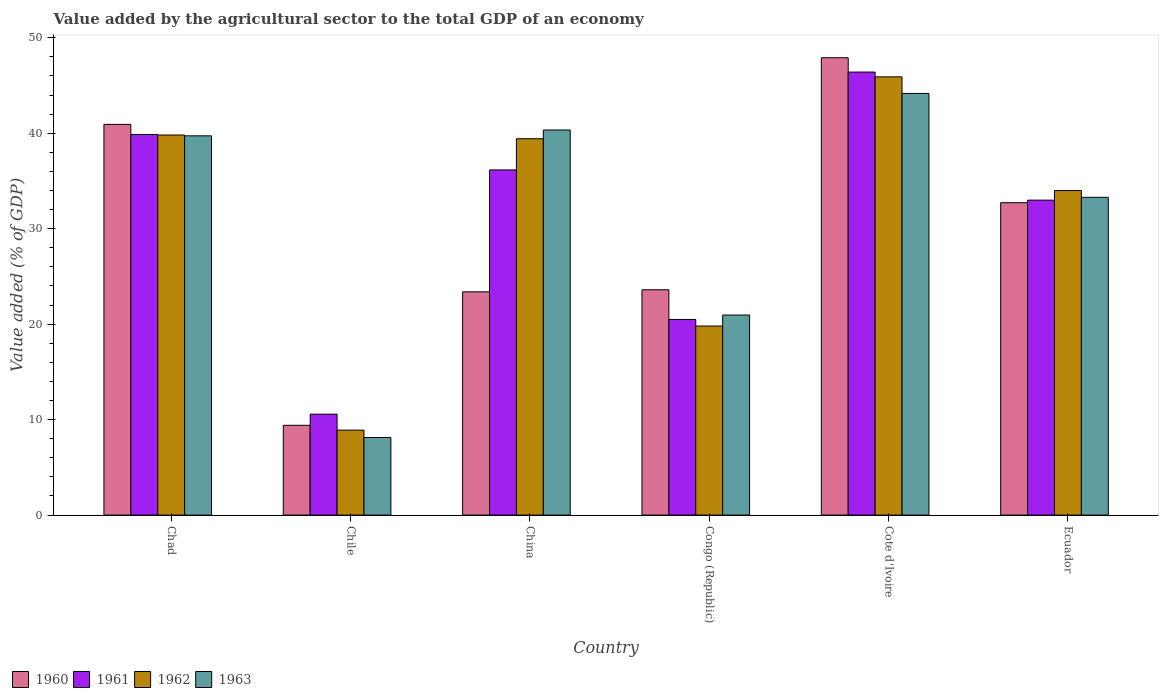How many different coloured bars are there?
Your answer should be very brief. 4. How many groups of bars are there?
Offer a terse response. 6. Are the number of bars per tick equal to the number of legend labels?
Provide a short and direct response. Yes. What is the label of the 3rd group of bars from the left?
Ensure brevity in your answer.  China. What is the value added by the agricultural sector to the total GDP in 1961 in Ecuador?
Give a very brief answer. 32.99. Across all countries, what is the maximum value added by the agricultural sector to the total GDP in 1963?
Offer a terse response. 44.17. Across all countries, what is the minimum value added by the agricultural sector to the total GDP in 1963?
Your response must be concise. 8.13. In which country was the value added by the agricultural sector to the total GDP in 1960 maximum?
Give a very brief answer. Cote d'Ivoire. In which country was the value added by the agricultural sector to the total GDP in 1963 minimum?
Provide a succinct answer. Chile. What is the total value added by the agricultural sector to the total GDP in 1960 in the graph?
Offer a very short reply. 177.94. What is the difference between the value added by the agricultural sector to the total GDP in 1961 in Cote d'Ivoire and that in Ecuador?
Make the answer very short. 13.42. What is the difference between the value added by the agricultural sector to the total GDP in 1961 in Ecuador and the value added by the agricultural sector to the total GDP in 1960 in Chile?
Your answer should be very brief. 23.59. What is the average value added by the agricultural sector to the total GDP in 1962 per country?
Your answer should be very brief. 31.31. What is the difference between the value added by the agricultural sector to the total GDP of/in 1962 and value added by the agricultural sector to the total GDP of/in 1963 in Cote d'Ivoire?
Offer a very short reply. 1.74. In how many countries, is the value added by the agricultural sector to the total GDP in 1962 greater than 12 %?
Keep it short and to the point. 5. What is the ratio of the value added by the agricultural sector to the total GDP in 1962 in Congo (Republic) to that in Cote d'Ivoire?
Provide a short and direct response. 0.43. Is the difference between the value added by the agricultural sector to the total GDP in 1962 in Congo (Republic) and Ecuador greater than the difference between the value added by the agricultural sector to the total GDP in 1963 in Congo (Republic) and Ecuador?
Offer a terse response. No. What is the difference between the highest and the second highest value added by the agricultural sector to the total GDP in 1961?
Give a very brief answer. -10.25. What is the difference between the highest and the lowest value added by the agricultural sector to the total GDP in 1963?
Keep it short and to the point. 36.04. In how many countries, is the value added by the agricultural sector to the total GDP in 1962 greater than the average value added by the agricultural sector to the total GDP in 1962 taken over all countries?
Ensure brevity in your answer.  4. Is the sum of the value added by the agricultural sector to the total GDP in 1963 in Chad and China greater than the maximum value added by the agricultural sector to the total GDP in 1961 across all countries?
Your answer should be very brief. Yes. What does the 4th bar from the left in Chad represents?
Offer a terse response. 1963. What does the 1st bar from the right in Chad represents?
Offer a very short reply. 1963. How many bars are there?
Make the answer very short. 24. Are all the bars in the graph horizontal?
Offer a terse response. No. What is the difference between two consecutive major ticks on the Y-axis?
Your response must be concise. 10. Where does the legend appear in the graph?
Give a very brief answer. Bottom left. How many legend labels are there?
Provide a succinct answer. 4. How are the legend labels stacked?
Provide a short and direct response. Horizontal. What is the title of the graph?
Keep it short and to the point. Value added by the agricultural sector to the total GDP of an economy. Does "1978" appear as one of the legend labels in the graph?
Your answer should be compact. No. What is the label or title of the X-axis?
Offer a terse response. Country. What is the label or title of the Y-axis?
Provide a succinct answer. Value added (% of GDP). What is the Value added (% of GDP) in 1960 in Chad?
Ensure brevity in your answer.  40.93. What is the Value added (% of GDP) of 1961 in Chad?
Your response must be concise. 39.87. What is the Value added (% of GDP) in 1962 in Chad?
Keep it short and to the point. 39.81. What is the Value added (% of GDP) of 1963 in Chad?
Your answer should be very brief. 39.73. What is the Value added (% of GDP) of 1960 in Chile?
Make the answer very short. 9.4. What is the Value added (% of GDP) of 1961 in Chile?
Ensure brevity in your answer.  10.57. What is the Value added (% of GDP) of 1962 in Chile?
Give a very brief answer. 8.9. What is the Value added (% of GDP) in 1963 in Chile?
Make the answer very short. 8.13. What is the Value added (% of GDP) in 1960 in China?
Provide a succinct answer. 23.38. What is the Value added (% of GDP) of 1961 in China?
Offer a very short reply. 36.16. What is the Value added (% of GDP) in 1962 in China?
Offer a terse response. 39.42. What is the Value added (% of GDP) of 1963 in China?
Your answer should be compact. 40.34. What is the Value added (% of GDP) in 1960 in Congo (Republic)?
Provide a short and direct response. 23.6. What is the Value added (% of GDP) in 1961 in Congo (Republic)?
Your answer should be compact. 20.49. What is the Value added (% of GDP) in 1962 in Congo (Republic)?
Your answer should be compact. 19.8. What is the Value added (% of GDP) in 1963 in Congo (Republic)?
Ensure brevity in your answer.  20.95. What is the Value added (% of GDP) in 1960 in Cote d'Ivoire?
Your response must be concise. 47.91. What is the Value added (% of GDP) of 1961 in Cote d'Ivoire?
Give a very brief answer. 46.41. What is the Value added (% of GDP) in 1962 in Cote d'Ivoire?
Make the answer very short. 45.9. What is the Value added (% of GDP) of 1963 in Cote d'Ivoire?
Give a very brief answer. 44.17. What is the Value added (% of GDP) in 1960 in Ecuador?
Make the answer very short. 32.72. What is the Value added (% of GDP) of 1961 in Ecuador?
Your answer should be compact. 32.99. What is the Value added (% of GDP) in 1962 in Ecuador?
Ensure brevity in your answer.  33.99. What is the Value added (% of GDP) in 1963 in Ecuador?
Your answer should be very brief. 33.29. Across all countries, what is the maximum Value added (% of GDP) in 1960?
Provide a short and direct response. 47.91. Across all countries, what is the maximum Value added (% of GDP) in 1961?
Provide a short and direct response. 46.41. Across all countries, what is the maximum Value added (% of GDP) in 1962?
Provide a short and direct response. 45.9. Across all countries, what is the maximum Value added (% of GDP) of 1963?
Give a very brief answer. 44.17. Across all countries, what is the minimum Value added (% of GDP) in 1960?
Ensure brevity in your answer.  9.4. Across all countries, what is the minimum Value added (% of GDP) of 1961?
Make the answer very short. 10.57. Across all countries, what is the minimum Value added (% of GDP) of 1962?
Your answer should be very brief. 8.9. Across all countries, what is the minimum Value added (% of GDP) in 1963?
Your answer should be compact. 8.13. What is the total Value added (% of GDP) in 1960 in the graph?
Your answer should be very brief. 177.94. What is the total Value added (% of GDP) in 1961 in the graph?
Provide a short and direct response. 186.48. What is the total Value added (% of GDP) in 1962 in the graph?
Your answer should be compact. 187.84. What is the total Value added (% of GDP) of 1963 in the graph?
Ensure brevity in your answer.  186.6. What is the difference between the Value added (% of GDP) in 1960 in Chad and that in Chile?
Make the answer very short. 31.52. What is the difference between the Value added (% of GDP) in 1961 in Chad and that in Chile?
Your answer should be compact. 29.3. What is the difference between the Value added (% of GDP) in 1962 in Chad and that in Chile?
Your answer should be compact. 30.91. What is the difference between the Value added (% of GDP) of 1963 in Chad and that in Chile?
Your response must be concise. 31.6. What is the difference between the Value added (% of GDP) of 1960 in Chad and that in China?
Your answer should be compact. 17.54. What is the difference between the Value added (% of GDP) of 1961 in Chad and that in China?
Offer a very short reply. 3.71. What is the difference between the Value added (% of GDP) in 1962 in Chad and that in China?
Offer a terse response. 0.39. What is the difference between the Value added (% of GDP) in 1963 in Chad and that in China?
Ensure brevity in your answer.  -0.61. What is the difference between the Value added (% of GDP) of 1960 in Chad and that in Congo (Republic)?
Provide a succinct answer. 17.33. What is the difference between the Value added (% of GDP) in 1961 in Chad and that in Congo (Republic)?
Provide a short and direct response. 19.38. What is the difference between the Value added (% of GDP) in 1962 in Chad and that in Congo (Republic)?
Give a very brief answer. 20.01. What is the difference between the Value added (% of GDP) in 1963 in Chad and that in Congo (Republic)?
Keep it short and to the point. 18.77. What is the difference between the Value added (% of GDP) of 1960 in Chad and that in Cote d'Ivoire?
Provide a succinct answer. -6.98. What is the difference between the Value added (% of GDP) of 1961 in Chad and that in Cote d'Ivoire?
Make the answer very short. -6.54. What is the difference between the Value added (% of GDP) of 1962 in Chad and that in Cote d'Ivoire?
Give a very brief answer. -6.09. What is the difference between the Value added (% of GDP) of 1963 in Chad and that in Cote d'Ivoire?
Give a very brief answer. -4.44. What is the difference between the Value added (% of GDP) in 1960 in Chad and that in Ecuador?
Keep it short and to the point. 8.21. What is the difference between the Value added (% of GDP) of 1961 in Chad and that in Ecuador?
Keep it short and to the point. 6.88. What is the difference between the Value added (% of GDP) of 1962 in Chad and that in Ecuador?
Your answer should be compact. 5.82. What is the difference between the Value added (% of GDP) of 1963 in Chad and that in Ecuador?
Offer a very short reply. 6.44. What is the difference between the Value added (% of GDP) of 1960 in Chile and that in China?
Provide a short and direct response. -13.98. What is the difference between the Value added (% of GDP) of 1961 in Chile and that in China?
Offer a very short reply. -25.58. What is the difference between the Value added (% of GDP) in 1962 in Chile and that in China?
Give a very brief answer. -30.52. What is the difference between the Value added (% of GDP) of 1963 in Chile and that in China?
Make the answer very short. -32.21. What is the difference between the Value added (% of GDP) of 1960 in Chile and that in Congo (Republic)?
Provide a short and direct response. -14.2. What is the difference between the Value added (% of GDP) of 1961 in Chile and that in Congo (Republic)?
Your answer should be compact. -9.92. What is the difference between the Value added (% of GDP) of 1962 in Chile and that in Congo (Republic)?
Make the answer very short. -10.91. What is the difference between the Value added (% of GDP) in 1963 in Chile and that in Congo (Republic)?
Offer a very short reply. -12.83. What is the difference between the Value added (% of GDP) in 1960 in Chile and that in Cote d'Ivoire?
Your answer should be very brief. -38.5. What is the difference between the Value added (% of GDP) in 1961 in Chile and that in Cote d'Ivoire?
Offer a very short reply. -35.84. What is the difference between the Value added (% of GDP) in 1962 in Chile and that in Cote d'Ivoire?
Ensure brevity in your answer.  -37. What is the difference between the Value added (% of GDP) of 1963 in Chile and that in Cote d'Ivoire?
Your answer should be very brief. -36.04. What is the difference between the Value added (% of GDP) in 1960 in Chile and that in Ecuador?
Provide a succinct answer. -23.32. What is the difference between the Value added (% of GDP) of 1961 in Chile and that in Ecuador?
Offer a very short reply. -22.42. What is the difference between the Value added (% of GDP) in 1962 in Chile and that in Ecuador?
Keep it short and to the point. -25.09. What is the difference between the Value added (% of GDP) of 1963 in Chile and that in Ecuador?
Keep it short and to the point. -25.16. What is the difference between the Value added (% of GDP) in 1960 in China and that in Congo (Republic)?
Your response must be concise. -0.22. What is the difference between the Value added (% of GDP) in 1961 in China and that in Congo (Republic)?
Your answer should be compact. 15.66. What is the difference between the Value added (% of GDP) in 1962 in China and that in Congo (Republic)?
Provide a short and direct response. 19.62. What is the difference between the Value added (% of GDP) in 1963 in China and that in Congo (Republic)?
Ensure brevity in your answer.  19.38. What is the difference between the Value added (% of GDP) in 1960 in China and that in Cote d'Ivoire?
Offer a very short reply. -24.52. What is the difference between the Value added (% of GDP) of 1961 in China and that in Cote d'Ivoire?
Your answer should be very brief. -10.25. What is the difference between the Value added (% of GDP) in 1962 in China and that in Cote d'Ivoire?
Offer a terse response. -6.48. What is the difference between the Value added (% of GDP) of 1963 in China and that in Cote d'Ivoire?
Your answer should be very brief. -3.83. What is the difference between the Value added (% of GDP) in 1960 in China and that in Ecuador?
Keep it short and to the point. -9.34. What is the difference between the Value added (% of GDP) in 1961 in China and that in Ecuador?
Provide a short and direct response. 3.17. What is the difference between the Value added (% of GDP) in 1962 in China and that in Ecuador?
Your answer should be compact. 5.43. What is the difference between the Value added (% of GDP) in 1963 in China and that in Ecuador?
Your answer should be compact. 7.05. What is the difference between the Value added (% of GDP) of 1960 in Congo (Republic) and that in Cote d'Ivoire?
Give a very brief answer. -24.31. What is the difference between the Value added (% of GDP) in 1961 in Congo (Republic) and that in Cote d'Ivoire?
Offer a very short reply. -25.91. What is the difference between the Value added (% of GDP) of 1962 in Congo (Republic) and that in Cote d'Ivoire?
Your answer should be compact. -26.1. What is the difference between the Value added (% of GDP) of 1963 in Congo (Republic) and that in Cote d'Ivoire?
Offer a terse response. -23.21. What is the difference between the Value added (% of GDP) in 1960 in Congo (Republic) and that in Ecuador?
Offer a terse response. -9.12. What is the difference between the Value added (% of GDP) in 1961 in Congo (Republic) and that in Ecuador?
Your response must be concise. -12.5. What is the difference between the Value added (% of GDP) of 1962 in Congo (Republic) and that in Ecuador?
Keep it short and to the point. -14.19. What is the difference between the Value added (% of GDP) in 1963 in Congo (Republic) and that in Ecuador?
Offer a terse response. -12.33. What is the difference between the Value added (% of GDP) of 1960 in Cote d'Ivoire and that in Ecuador?
Make the answer very short. 15.19. What is the difference between the Value added (% of GDP) of 1961 in Cote d'Ivoire and that in Ecuador?
Make the answer very short. 13.42. What is the difference between the Value added (% of GDP) in 1962 in Cote d'Ivoire and that in Ecuador?
Keep it short and to the point. 11.91. What is the difference between the Value added (% of GDP) in 1963 in Cote d'Ivoire and that in Ecuador?
Provide a succinct answer. 10.88. What is the difference between the Value added (% of GDP) in 1960 in Chad and the Value added (% of GDP) in 1961 in Chile?
Your response must be concise. 30.36. What is the difference between the Value added (% of GDP) in 1960 in Chad and the Value added (% of GDP) in 1962 in Chile?
Your answer should be compact. 32.03. What is the difference between the Value added (% of GDP) of 1960 in Chad and the Value added (% of GDP) of 1963 in Chile?
Offer a terse response. 32.8. What is the difference between the Value added (% of GDP) of 1961 in Chad and the Value added (% of GDP) of 1962 in Chile?
Offer a terse response. 30.97. What is the difference between the Value added (% of GDP) in 1961 in Chad and the Value added (% of GDP) in 1963 in Chile?
Offer a very short reply. 31.74. What is the difference between the Value added (% of GDP) in 1962 in Chad and the Value added (% of GDP) in 1963 in Chile?
Provide a short and direct response. 31.69. What is the difference between the Value added (% of GDP) in 1960 in Chad and the Value added (% of GDP) in 1961 in China?
Make the answer very short. 4.77. What is the difference between the Value added (% of GDP) of 1960 in Chad and the Value added (% of GDP) of 1962 in China?
Make the answer very short. 1.5. What is the difference between the Value added (% of GDP) in 1960 in Chad and the Value added (% of GDP) in 1963 in China?
Provide a succinct answer. 0.59. What is the difference between the Value added (% of GDP) in 1961 in Chad and the Value added (% of GDP) in 1962 in China?
Your answer should be compact. 0.44. What is the difference between the Value added (% of GDP) in 1961 in Chad and the Value added (% of GDP) in 1963 in China?
Provide a succinct answer. -0.47. What is the difference between the Value added (% of GDP) of 1962 in Chad and the Value added (% of GDP) of 1963 in China?
Provide a succinct answer. -0.53. What is the difference between the Value added (% of GDP) of 1960 in Chad and the Value added (% of GDP) of 1961 in Congo (Republic)?
Your answer should be compact. 20.44. What is the difference between the Value added (% of GDP) of 1960 in Chad and the Value added (% of GDP) of 1962 in Congo (Republic)?
Ensure brevity in your answer.  21.12. What is the difference between the Value added (% of GDP) of 1960 in Chad and the Value added (% of GDP) of 1963 in Congo (Republic)?
Keep it short and to the point. 19.97. What is the difference between the Value added (% of GDP) of 1961 in Chad and the Value added (% of GDP) of 1962 in Congo (Republic)?
Provide a short and direct response. 20.06. What is the difference between the Value added (% of GDP) in 1961 in Chad and the Value added (% of GDP) in 1963 in Congo (Republic)?
Make the answer very short. 18.91. What is the difference between the Value added (% of GDP) in 1962 in Chad and the Value added (% of GDP) in 1963 in Congo (Republic)?
Provide a succinct answer. 18.86. What is the difference between the Value added (% of GDP) in 1960 in Chad and the Value added (% of GDP) in 1961 in Cote d'Ivoire?
Give a very brief answer. -5.48. What is the difference between the Value added (% of GDP) of 1960 in Chad and the Value added (% of GDP) of 1962 in Cote d'Ivoire?
Offer a terse response. -4.98. What is the difference between the Value added (% of GDP) in 1960 in Chad and the Value added (% of GDP) in 1963 in Cote d'Ivoire?
Offer a very short reply. -3.24. What is the difference between the Value added (% of GDP) in 1961 in Chad and the Value added (% of GDP) in 1962 in Cote d'Ivoire?
Keep it short and to the point. -6.04. What is the difference between the Value added (% of GDP) in 1961 in Chad and the Value added (% of GDP) in 1963 in Cote d'Ivoire?
Offer a very short reply. -4.3. What is the difference between the Value added (% of GDP) in 1962 in Chad and the Value added (% of GDP) in 1963 in Cote d'Ivoire?
Ensure brevity in your answer.  -4.36. What is the difference between the Value added (% of GDP) in 1960 in Chad and the Value added (% of GDP) in 1961 in Ecuador?
Provide a succinct answer. 7.94. What is the difference between the Value added (% of GDP) of 1960 in Chad and the Value added (% of GDP) of 1962 in Ecuador?
Make the answer very short. 6.93. What is the difference between the Value added (% of GDP) of 1960 in Chad and the Value added (% of GDP) of 1963 in Ecuador?
Your response must be concise. 7.64. What is the difference between the Value added (% of GDP) of 1961 in Chad and the Value added (% of GDP) of 1962 in Ecuador?
Provide a short and direct response. 5.87. What is the difference between the Value added (% of GDP) of 1961 in Chad and the Value added (% of GDP) of 1963 in Ecuador?
Keep it short and to the point. 6.58. What is the difference between the Value added (% of GDP) in 1962 in Chad and the Value added (% of GDP) in 1963 in Ecuador?
Give a very brief answer. 6.52. What is the difference between the Value added (% of GDP) in 1960 in Chile and the Value added (% of GDP) in 1961 in China?
Provide a short and direct response. -26.75. What is the difference between the Value added (% of GDP) in 1960 in Chile and the Value added (% of GDP) in 1962 in China?
Give a very brief answer. -30.02. What is the difference between the Value added (% of GDP) in 1960 in Chile and the Value added (% of GDP) in 1963 in China?
Offer a terse response. -30.93. What is the difference between the Value added (% of GDP) of 1961 in Chile and the Value added (% of GDP) of 1962 in China?
Give a very brief answer. -28.85. What is the difference between the Value added (% of GDP) of 1961 in Chile and the Value added (% of GDP) of 1963 in China?
Provide a short and direct response. -29.77. What is the difference between the Value added (% of GDP) of 1962 in Chile and the Value added (% of GDP) of 1963 in China?
Your response must be concise. -31.44. What is the difference between the Value added (% of GDP) of 1960 in Chile and the Value added (% of GDP) of 1961 in Congo (Republic)?
Your response must be concise. -11.09. What is the difference between the Value added (% of GDP) in 1960 in Chile and the Value added (% of GDP) in 1962 in Congo (Republic)?
Your answer should be compact. -10.4. What is the difference between the Value added (% of GDP) in 1960 in Chile and the Value added (% of GDP) in 1963 in Congo (Republic)?
Ensure brevity in your answer.  -11.55. What is the difference between the Value added (% of GDP) of 1961 in Chile and the Value added (% of GDP) of 1962 in Congo (Republic)?
Your answer should be compact. -9.23. What is the difference between the Value added (% of GDP) of 1961 in Chile and the Value added (% of GDP) of 1963 in Congo (Republic)?
Make the answer very short. -10.38. What is the difference between the Value added (% of GDP) of 1962 in Chile and the Value added (% of GDP) of 1963 in Congo (Republic)?
Provide a succinct answer. -12.05. What is the difference between the Value added (% of GDP) in 1960 in Chile and the Value added (% of GDP) in 1961 in Cote d'Ivoire?
Keep it short and to the point. -37. What is the difference between the Value added (% of GDP) in 1960 in Chile and the Value added (% of GDP) in 1962 in Cote d'Ivoire?
Provide a short and direct response. -36.5. What is the difference between the Value added (% of GDP) of 1960 in Chile and the Value added (% of GDP) of 1963 in Cote d'Ivoire?
Offer a very short reply. -34.76. What is the difference between the Value added (% of GDP) in 1961 in Chile and the Value added (% of GDP) in 1962 in Cote d'Ivoire?
Make the answer very short. -35.33. What is the difference between the Value added (% of GDP) in 1961 in Chile and the Value added (% of GDP) in 1963 in Cote d'Ivoire?
Your response must be concise. -33.6. What is the difference between the Value added (% of GDP) of 1962 in Chile and the Value added (% of GDP) of 1963 in Cote d'Ivoire?
Give a very brief answer. -35.27. What is the difference between the Value added (% of GDP) in 1960 in Chile and the Value added (% of GDP) in 1961 in Ecuador?
Make the answer very short. -23.59. What is the difference between the Value added (% of GDP) in 1960 in Chile and the Value added (% of GDP) in 1962 in Ecuador?
Keep it short and to the point. -24.59. What is the difference between the Value added (% of GDP) of 1960 in Chile and the Value added (% of GDP) of 1963 in Ecuador?
Give a very brief answer. -23.88. What is the difference between the Value added (% of GDP) in 1961 in Chile and the Value added (% of GDP) in 1962 in Ecuador?
Your answer should be compact. -23.42. What is the difference between the Value added (% of GDP) in 1961 in Chile and the Value added (% of GDP) in 1963 in Ecuador?
Ensure brevity in your answer.  -22.72. What is the difference between the Value added (% of GDP) of 1962 in Chile and the Value added (% of GDP) of 1963 in Ecuador?
Keep it short and to the point. -24.39. What is the difference between the Value added (% of GDP) of 1960 in China and the Value added (% of GDP) of 1961 in Congo (Republic)?
Offer a very short reply. 2.89. What is the difference between the Value added (% of GDP) of 1960 in China and the Value added (% of GDP) of 1962 in Congo (Republic)?
Your answer should be compact. 3.58. What is the difference between the Value added (% of GDP) of 1960 in China and the Value added (% of GDP) of 1963 in Congo (Republic)?
Offer a terse response. 2.43. What is the difference between the Value added (% of GDP) of 1961 in China and the Value added (% of GDP) of 1962 in Congo (Republic)?
Make the answer very short. 16.35. What is the difference between the Value added (% of GDP) in 1961 in China and the Value added (% of GDP) in 1963 in Congo (Republic)?
Make the answer very short. 15.2. What is the difference between the Value added (% of GDP) in 1962 in China and the Value added (% of GDP) in 1963 in Congo (Republic)?
Give a very brief answer. 18.47. What is the difference between the Value added (% of GDP) in 1960 in China and the Value added (% of GDP) in 1961 in Cote d'Ivoire?
Offer a very short reply. -23.02. What is the difference between the Value added (% of GDP) of 1960 in China and the Value added (% of GDP) of 1962 in Cote d'Ivoire?
Ensure brevity in your answer.  -22.52. What is the difference between the Value added (% of GDP) of 1960 in China and the Value added (% of GDP) of 1963 in Cote d'Ivoire?
Keep it short and to the point. -20.78. What is the difference between the Value added (% of GDP) of 1961 in China and the Value added (% of GDP) of 1962 in Cote d'Ivoire?
Offer a terse response. -9.75. What is the difference between the Value added (% of GDP) of 1961 in China and the Value added (% of GDP) of 1963 in Cote d'Ivoire?
Offer a terse response. -8.01. What is the difference between the Value added (% of GDP) in 1962 in China and the Value added (% of GDP) in 1963 in Cote d'Ivoire?
Make the answer very short. -4.74. What is the difference between the Value added (% of GDP) in 1960 in China and the Value added (% of GDP) in 1961 in Ecuador?
Make the answer very short. -9.61. What is the difference between the Value added (% of GDP) in 1960 in China and the Value added (% of GDP) in 1962 in Ecuador?
Your response must be concise. -10.61. What is the difference between the Value added (% of GDP) of 1960 in China and the Value added (% of GDP) of 1963 in Ecuador?
Offer a terse response. -9.9. What is the difference between the Value added (% of GDP) of 1961 in China and the Value added (% of GDP) of 1962 in Ecuador?
Your answer should be very brief. 2.16. What is the difference between the Value added (% of GDP) in 1961 in China and the Value added (% of GDP) in 1963 in Ecuador?
Make the answer very short. 2.87. What is the difference between the Value added (% of GDP) of 1962 in China and the Value added (% of GDP) of 1963 in Ecuador?
Make the answer very short. 6.14. What is the difference between the Value added (% of GDP) of 1960 in Congo (Republic) and the Value added (% of GDP) of 1961 in Cote d'Ivoire?
Provide a short and direct response. -22.81. What is the difference between the Value added (% of GDP) of 1960 in Congo (Republic) and the Value added (% of GDP) of 1962 in Cote d'Ivoire?
Your response must be concise. -22.3. What is the difference between the Value added (% of GDP) in 1960 in Congo (Republic) and the Value added (% of GDP) in 1963 in Cote d'Ivoire?
Offer a very short reply. -20.57. What is the difference between the Value added (% of GDP) of 1961 in Congo (Republic) and the Value added (% of GDP) of 1962 in Cote d'Ivoire?
Make the answer very short. -25.41. What is the difference between the Value added (% of GDP) of 1961 in Congo (Republic) and the Value added (% of GDP) of 1963 in Cote d'Ivoire?
Your answer should be compact. -23.68. What is the difference between the Value added (% of GDP) in 1962 in Congo (Republic) and the Value added (% of GDP) in 1963 in Cote d'Ivoire?
Offer a very short reply. -24.36. What is the difference between the Value added (% of GDP) in 1960 in Congo (Republic) and the Value added (% of GDP) in 1961 in Ecuador?
Offer a very short reply. -9.39. What is the difference between the Value added (% of GDP) in 1960 in Congo (Republic) and the Value added (% of GDP) in 1962 in Ecuador?
Your answer should be very brief. -10.39. What is the difference between the Value added (% of GDP) of 1960 in Congo (Republic) and the Value added (% of GDP) of 1963 in Ecuador?
Keep it short and to the point. -9.69. What is the difference between the Value added (% of GDP) in 1961 in Congo (Republic) and the Value added (% of GDP) in 1962 in Ecuador?
Your answer should be compact. -13.5. What is the difference between the Value added (% of GDP) of 1961 in Congo (Republic) and the Value added (% of GDP) of 1963 in Ecuador?
Provide a short and direct response. -12.8. What is the difference between the Value added (% of GDP) of 1962 in Congo (Republic) and the Value added (% of GDP) of 1963 in Ecuador?
Offer a very short reply. -13.48. What is the difference between the Value added (% of GDP) of 1960 in Cote d'Ivoire and the Value added (% of GDP) of 1961 in Ecuador?
Give a very brief answer. 14.92. What is the difference between the Value added (% of GDP) in 1960 in Cote d'Ivoire and the Value added (% of GDP) in 1962 in Ecuador?
Make the answer very short. 13.91. What is the difference between the Value added (% of GDP) of 1960 in Cote d'Ivoire and the Value added (% of GDP) of 1963 in Ecuador?
Give a very brief answer. 14.62. What is the difference between the Value added (% of GDP) in 1961 in Cote d'Ivoire and the Value added (% of GDP) in 1962 in Ecuador?
Offer a very short reply. 12.41. What is the difference between the Value added (% of GDP) in 1961 in Cote d'Ivoire and the Value added (% of GDP) in 1963 in Ecuador?
Provide a short and direct response. 13.12. What is the difference between the Value added (% of GDP) of 1962 in Cote d'Ivoire and the Value added (% of GDP) of 1963 in Ecuador?
Ensure brevity in your answer.  12.62. What is the average Value added (% of GDP) of 1960 per country?
Provide a succinct answer. 29.66. What is the average Value added (% of GDP) in 1961 per country?
Offer a terse response. 31.08. What is the average Value added (% of GDP) in 1962 per country?
Ensure brevity in your answer.  31.31. What is the average Value added (% of GDP) in 1963 per country?
Your answer should be very brief. 31.1. What is the difference between the Value added (% of GDP) of 1960 and Value added (% of GDP) of 1961 in Chad?
Provide a short and direct response. 1.06. What is the difference between the Value added (% of GDP) of 1960 and Value added (% of GDP) of 1962 in Chad?
Provide a succinct answer. 1.11. What is the difference between the Value added (% of GDP) in 1960 and Value added (% of GDP) in 1963 in Chad?
Provide a short and direct response. 1.2. What is the difference between the Value added (% of GDP) in 1961 and Value added (% of GDP) in 1962 in Chad?
Give a very brief answer. 0.06. What is the difference between the Value added (% of GDP) of 1961 and Value added (% of GDP) of 1963 in Chad?
Ensure brevity in your answer.  0.14. What is the difference between the Value added (% of GDP) in 1962 and Value added (% of GDP) in 1963 in Chad?
Your response must be concise. 0.09. What is the difference between the Value added (% of GDP) in 1960 and Value added (% of GDP) in 1961 in Chile?
Offer a very short reply. -1.17. What is the difference between the Value added (% of GDP) of 1960 and Value added (% of GDP) of 1962 in Chile?
Ensure brevity in your answer.  0.51. What is the difference between the Value added (% of GDP) of 1960 and Value added (% of GDP) of 1963 in Chile?
Offer a terse response. 1.28. What is the difference between the Value added (% of GDP) in 1961 and Value added (% of GDP) in 1962 in Chile?
Offer a very short reply. 1.67. What is the difference between the Value added (% of GDP) in 1961 and Value added (% of GDP) in 1963 in Chile?
Provide a succinct answer. 2.45. What is the difference between the Value added (% of GDP) of 1962 and Value added (% of GDP) of 1963 in Chile?
Your answer should be compact. 0.77. What is the difference between the Value added (% of GDP) of 1960 and Value added (% of GDP) of 1961 in China?
Offer a very short reply. -12.77. What is the difference between the Value added (% of GDP) of 1960 and Value added (% of GDP) of 1962 in China?
Your answer should be compact. -16.04. What is the difference between the Value added (% of GDP) in 1960 and Value added (% of GDP) in 1963 in China?
Provide a short and direct response. -16.96. What is the difference between the Value added (% of GDP) in 1961 and Value added (% of GDP) in 1962 in China?
Give a very brief answer. -3.27. What is the difference between the Value added (% of GDP) of 1961 and Value added (% of GDP) of 1963 in China?
Your answer should be very brief. -4.18. What is the difference between the Value added (% of GDP) of 1962 and Value added (% of GDP) of 1963 in China?
Your response must be concise. -0.91. What is the difference between the Value added (% of GDP) of 1960 and Value added (% of GDP) of 1961 in Congo (Republic)?
Make the answer very short. 3.11. What is the difference between the Value added (% of GDP) of 1960 and Value added (% of GDP) of 1962 in Congo (Republic)?
Make the answer very short. 3.8. What is the difference between the Value added (% of GDP) of 1960 and Value added (% of GDP) of 1963 in Congo (Republic)?
Offer a very short reply. 2.65. What is the difference between the Value added (% of GDP) in 1961 and Value added (% of GDP) in 1962 in Congo (Republic)?
Ensure brevity in your answer.  0.69. What is the difference between the Value added (% of GDP) in 1961 and Value added (% of GDP) in 1963 in Congo (Republic)?
Your answer should be compact. -0.46. What is the difference between the Value added (% of GDP) of 1962 and Value added (% of GDP) of 1963 in Congo (Republic)?
Provide a succinct answer. -1.15. What is the difference between the Value added (% of GDP) of 1960 and Value added (% of GDP) of 1961 in Cote d'Ivoire?
Give a very brief answer. 1.5. What is the difference between the Value added (% of GDP) of 1960 and Value added (% of GDP) of 1962 in Cote d'Ivoire?
Give a very brief answer. 2. What is the difference between the Value added (% of GDP) in 1960 and Value added (% of GDP) in 1963 in Cote d'Ivoire?
Ensure brevity in your answer.  3.74. What is the difference between the Value added (% of GDP) in 1961 and Value added (% of GDP) in 1962 in Cote d'Ivoire?
Give a very brief answer. 0.5. What is the difference between the Value added (% of GDP) in 1961 and Value added (% of GDP) in 1963 in Cote d'Ivoire?
Give a very brief answer. 2.24. What is the difference between the Value added (% of GDP) of 1962 and Value added (% of GDP) of 1963 in Cote d'Ivoire?
Make the answer very short. 1.74. What is the difference between the Value added (% of GDP) of 1960 and Value added (% of GDP) of 1961 in Ecuador?
Provide a succinct answer. -0.27. What is the difference between the Value added (% of GDP) of 1960 and Value added (% of GDP) of 1962 in Ecuador?
Keep it short and to the point. -1.27. What is the difference between the Value added (% of GDP) in 1960 and Value added (% of GDP) in 1963 in Ecuador?
Ensure brevity in your answer.  -0.57. What is the difference between the Value added (% of GDP) of 1961 and Value added (% of GDP) of 1962 in Ecuador?
Offer a very short reply. -1. What is the difference between the Value added (% of GDP) of 1961 and Value added (% of GDP) of 1963 in Ecuador?
Ensure brevity in your answer.  -0.3. What is the difference between the Value added (% of GDP) in 1962 and Value added (% of GDP) in 1963 in Ecuador?
Keep it short and to the point. 0.71. What is the ratio of the Value added (% of GDP) in 1960 in Chad to that in Chile?
Your response must be concise. 4.35. What is the ratio of the Value added (% of GDP) of 1961 in Chad to that in Chile?
Keep it short and to the point. 3.77. What is the ratio of the Value added (% of GDP) in 1962 in Chad to that in Chile?
Make the answer very short. 4.47. What is the ratio of the Value added (% of GDP) in 1963 in Chad to that in Chile?
Your response must be concise. 4.89. What is the ratio of the Value added (% of GDP) in 1960 in Chad to that in China?
Your response must be concise. 1.75. What is the ratio of the Value added (% of GDP) of 1961 in Chad to that in China?
Give a very brief answer. 1.1. What is the ratio of the Value added (% of GDP) of 1962 in Chad to that in China?
Keep it short and to the point. 1.01. What is the ratio of the Value added (% of GDP) of 1963 in Chad to that in China?
Offer a very short reply. 0.98. What is the ratio of the Value added (% of GDP) of 1960 in Chad to that in Congo (Republic)?
Your answer should be compact. 1.73. What is the ratio of the Value added (% of GDP) in 1961 in Chad to that in Congo (Republic)?
Make the answer very short. 1.95. What is the ratio of the Value added (% of GDP) of 1962 in Chad to that in Congo (Republic)?
Provide a short and direct response. 2.01. What is the ratio of the Value added (% of GDP) in 1963 in Chad to that in Congo (Republic)?
Ensure brevity in your answer.  1.9. What is the ratio of the Value added (% of GDP) of 1960 in Chad to that in Cote d'Ivoire?
Provide a succinct answer. 0.85. What is the ratio of the Value added (% of GDP) of 1961 in Chad to that in Cote d'Ivoire?
Ensure brevity in your answer.  0.86. What is the ratio of the Value added (% of GDP) in 1962 in Chad to that in Cote d'Ivoire?
Make the answer very short. 0.87. What is the ratio of the Value added (% of GDP) of 1963 in Chad to that in Cote d'Ivoire?
Your answer should be very brief. 0.9. What is the ratio of the Value added (% of GDP) of 1960 in Chad to that in Ecuador?
Offer a very short reply. 1.25. What is the ratio of the Value added (% of GDP) in 1961 in Chad to that in Ecuador?
Give a very brief answer. 1.21. What is the ratio of the Value added (% of GDP) of 1962 in Chad to that in Ecuador?
Provide a short and direct response. 1.17. What is the ratio of the Value added (% of GDP) in 1963 in Chad to that in Ecuador?
Your answer should be very brief. 1.19. What is the ratio of the Value added (% of GDP) in 1960 in Chile to that in China?
Your answer should be compact. 0.4. What is the ratio of the Value added (% of GDP) of 1961 in Chile to that in China?
Your answer should be very brief. 0.29. What is the ratio of the Value added (% of GDP) of 1962 in Chile to that in China?
Offer a terse response. 0.23. What is the ratio of the Value added (% of GDP) in 1963 in Chile to that in China?
Provide a succinct answer. 0.2. What is the ratio of the Value added (% of GDP) of 1960 in Chile to that in Congo (Republic)?
Keep it short and to the point. 0.4. What is the ratio of the Value added (% of GDP) in 1961 in Chile to that in Congo (Republic)?
Keep it short and to the point. 0.52. What is the ratio of the Value added (% of GDP) in 1962 in Chile to that in Congo (Republic)?
Provide a succinct answer. 0.45. What is the ratio of the Value added (% of GDP) of 1963 in Chile to that in Congo (Republic)?
Provide a succinct answer. 0.39. What is the ratio of the Value added (% of GDP) of 1960 in Chile to that in Cote d'Ivoire?
Ensure brevity in your answer.  0.2. What is the ratio of the Value added (% of GDP) of 1961 in Chile to that in Cote d'Ivoire?
Give a very brief answer. 0.23. What is the ratio of the Value added (% of GDP) of 1962 in Chile to that in Cote d'Ivoire?
Provide a succinct answer. 0.19. What is the ratio of the Value added (% of GDP) in 1963 in Chile to that in Cote d'Ivoire?
Your answer should be very brief. 0.18. What is the ratio of the Value added (% of GDP) of 1960 in Chile to that in Ecuador?
Your response must be concise. 0.29. What is the ratio of the Value added (% of GDP) in 1961 in Chile to that in Ecuador?
Make the answer very short. 0.32. What is the ratio of the Value added (% of GDP) in 1962 in Chile to that in Ecuador?
Offer a very short reply. 0.26. What is the ratio of the Value added (% of GDP) of 1963 in Chile to that in Ecuador?
Your answer should be very brief. 0.24. What is the ratio of the Value added (% of GDP) in 1960 in China to that in Congo (Republic)?
Your response must be concise. 0.99. What is the ratio of the Value added (% of GDP) in 1961 in China to that in Congo (Republic)?
Offer a terse response. 1.76. What is the ratio of the Value added (% of GDP) in 1962 in China to that in Congo (Republic)?
Your answer should be very brief. 1.99. What is the ratio of the Value added (% of GDP) of 1963 in China to that in Congo (Republic)?
Offer a terse response. 1.93. What is the ratio of the Value added (% of GDP) in 1960 in China to that in Cote d'Ivoire?
Your answer should be very brief. 0.49. What is the ratio of the Value added (% of GDP) in 1961 in China to that in Cote d'Ivoire?
Your response must be concise. 0.78. What is the ratio of the Value added (% of GDP) in 1962 in China to that in Cote d'Ivoire?
Your answer should be compact. 0.86. What is the ratio of the Value added (% of GDP) of 1963 in China to that in Cote d'Ivoire?
Ensure brevity in your answer.  0.91. What is the ratio of the Value added (% of GDP) of 1960 in China to that in Ecuador?
Provide a short and direct response. 0.71. What is the ratio of the Value added (% of GDP) in 1961 in China to that in Ecuador?
Your response must be concise. 1.1. What is the ratio of the Value added (% of GDP) in 1962 in China to that in Ecuador?
Your answer should be compact. 1.16. What is the ratio of the Value added (% of GDP) in 1963 in China to that in Ecuador?
Offer a very short reply. 1.21. What is the ratio of the Value added (% of GDP) in 1960 in Congo (Republic) to that in Cote d'Ivoire?
Ensure brevity in your answer.  0.49. What is the ratio of the Value added (% of GDP) in 1961 in Congo (Republic) to that in Cote d'Ivoire?
Your response must be concise. 0.44. What is the ratio of the Value added (% of GDP) of 1962 in Congo (Republic) to that in Cote d'Ivoire?
Your response must be concise. 0.43. What is the ratio of the Value added (% of GDP) in 1963 in Congo (Republic) to that in Cote d'Ivoire?
Your answer should be compact. 0.47. What is the ratio of the Value added (% of GDP) of 1960 in Congo (Republic) to that in Ecuador?
Keep it short and to the point. 0.72. What is the ratio of the Value added (% of GDP) of 1961 in Congo (Republic) to that in Ecuador?
Your answer should be very brief. 0.62. What is the ratio of the Value added (% of GDP) of 1962 in Congo (Republic) to that in Ecuador?
Provide a short and direct response. 0.58. What is the ratio of the Value added (% of GDP) in 1963 in Congo (Republic) to that in Ecuador?
Ensure brevity in your answer.  0.63. What is the ratio of the Value added (% of GDP) of 1960 in Cote d'Ivoire to that in Ecuador?
Provide a succinct answer. 1.46. What is the ratio of the Value added (% of GDP) in 1961 in Cote d'Ivoire to that in Ecuador?
Offer a terse response. 1.41. What is the ratio of the Value added (% of GDP) in 1962 in Cote d'Ivoire to that in Ecuador?
Ensure brevity in your answer.  1.35. What is the ratio of the Value added (% of GDP) in 1963 in Cote d'Ivoire to that in Ecuador?
Your answer should be compact. 1.33. What is the difference between the highest and the second highest Value added (% of GDP) of 1960?
Keep it short and to the point. 6.98. What is the difference between the highest and the second highest Value added (% of GDP) of 1961?
Keep it short and to the point. 6.54. What is the difference between the highest and the second highest Value added (% of GDP) in 1962?
Offer a very short reply. 6.09. What is the difference between the highest and the second highest Value added (% of GDP) in 1963?
Your response must be concise. 3.83. What is the difference between the highest and the lowest Value added (% of GDP) of 1960?
Your answer should be compact. 38.5. What is the difference between the highest and the lowest Value added (% of GDP) in 1961?
Your answer should be compact. 35.84. What is the difference between the highest and the lowest Value added (% of GDP) in 1962?
Offer a very short reply. 37. What is the difference between the highest and the lowest Value added (% of GDP) in 1963?
Keep it short and to the point. 36.04. 